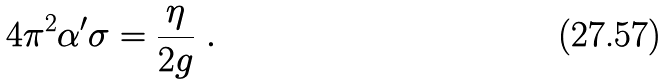Convert formula to latex. <formula><loc_0><loc_0><loc_500><loc_500>4 \pi ^ { 2 } \alpha ^ { \prime } \sigma = \frac { \eta } { 2 g } \ .</formula> 